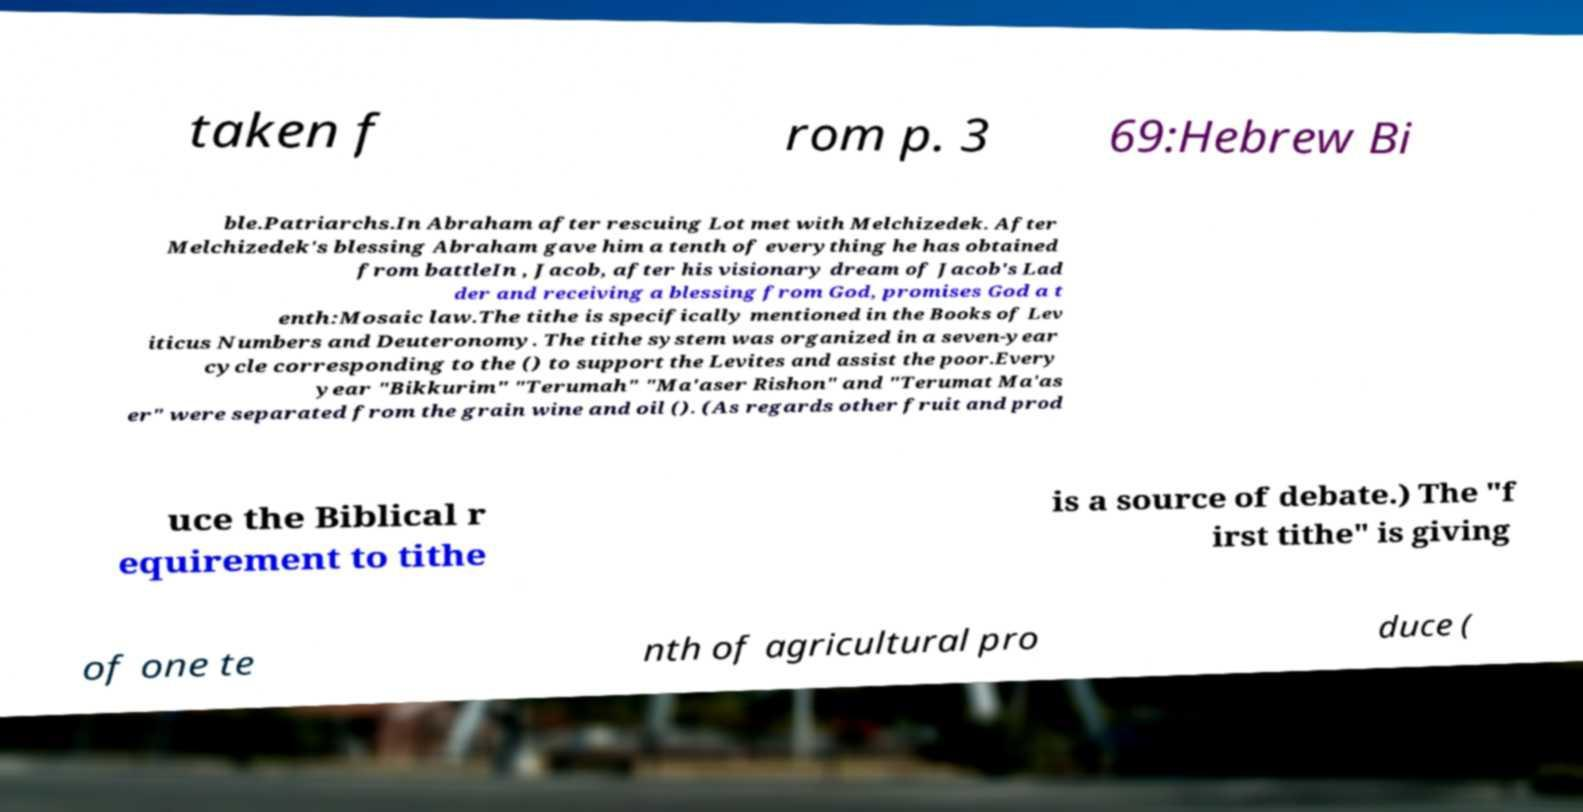Please read and relay the text visible in this image. What does it say? taken f rom p. 3 69:Hebrew Bi ble.Patriarchs.In Abraham after rescuing Lot met with Melchizedek. After Melchizedek's blessing Abraham gave him a tenth of everything he has obtained from battleIn , Jacob, after his visionary dream of Jacob's Lad der and receiving a blessing from God, promises God a t enth:Mosaic law.The tithe is specifically mentioned in the Books of Lev iticus Numbers and Deuteronomy. The tithe system was organized in a seven-year cycle corresponding to the () to support the Levites and assist the poor.Every year "Bikkurim" "Terumah" "Ma'aser Rishon" and "Terumat Ma'as er" were separated from the grain wine and oil (). (As regards other fruit and prod uce the Biblical r equirement to tithe is a source of debate.) The "f irst tithe" is giving of one te nth of agricultural pro duce ( 